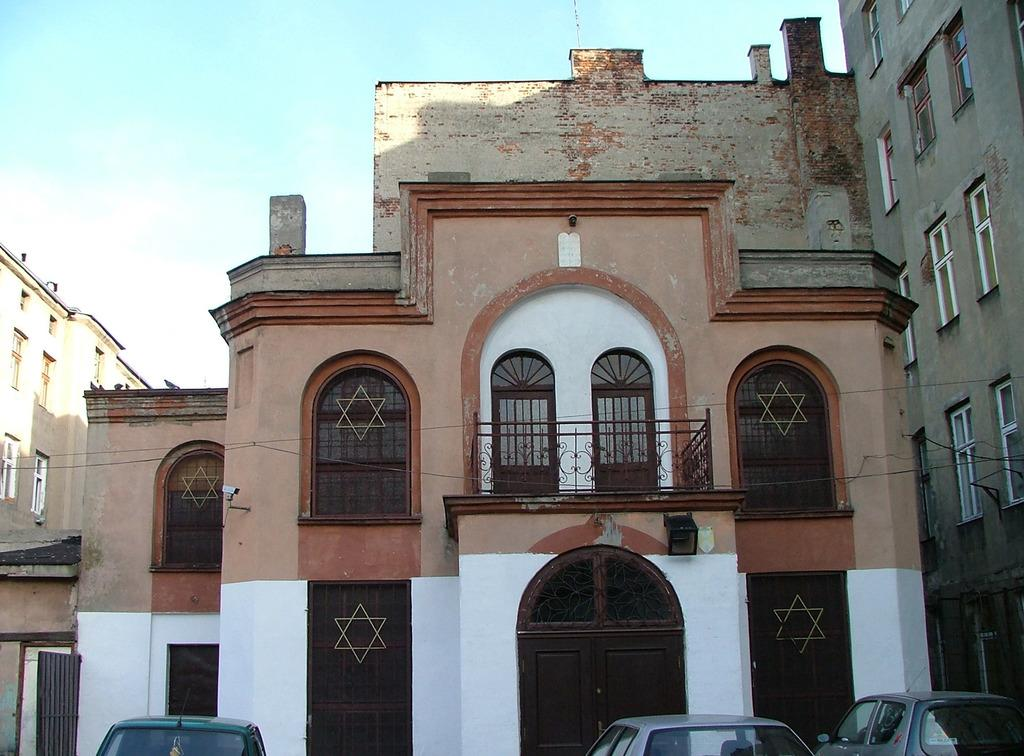What is occupying the path in the image? There are vehicles parked on the path in the image. What can be seen behind the vehicles? There are buildings behind the vehicles. What type of infrastructure is present in the image? Cables are present in the image. What is visible above the vehicles and buildings? The sky is visible in the image. Can you see any toes on the vehicles in the image? There are no toes present on the vehicles in the image. What type of nut is being used to secure the cables in the image? There is no nut visible in the image, as it focuses on vehicles, buildings, cables, and the sky. 